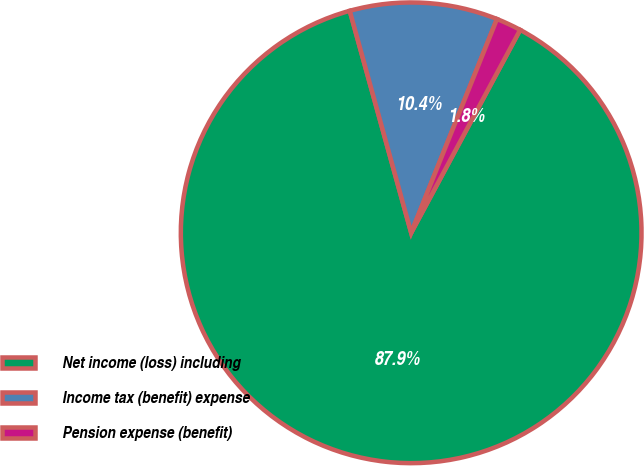Convert chart to OTSL. <chart><loc_0><loc_0><loc_500><loc_500><pie_chart><fcel>Net income (loss) including<fcel>Income tax (benefit) expense<fcel>Pension expense (benefit)<nl><fcel>87.86%<fcel>10.37%<fcel>1.77%<nl></chart> 